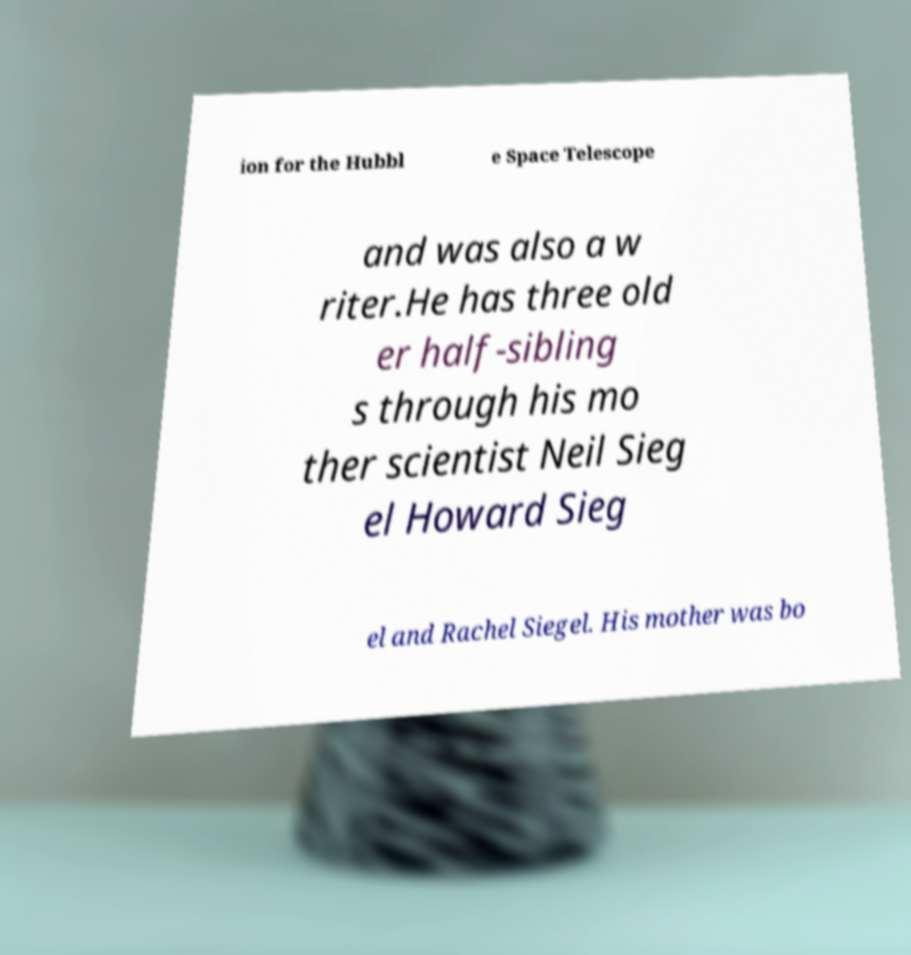Can you read and provide the text displayed in the image?This photo seems to have some interesting text. Can you extract and type it out for me? ion for the Hubbl e Space Telescope and was also a w riter.He has three old er half-sibling s through his mo ther scientist Neil Sieg el Howard Sieg el and Rachel Siegel. His mother was bo 